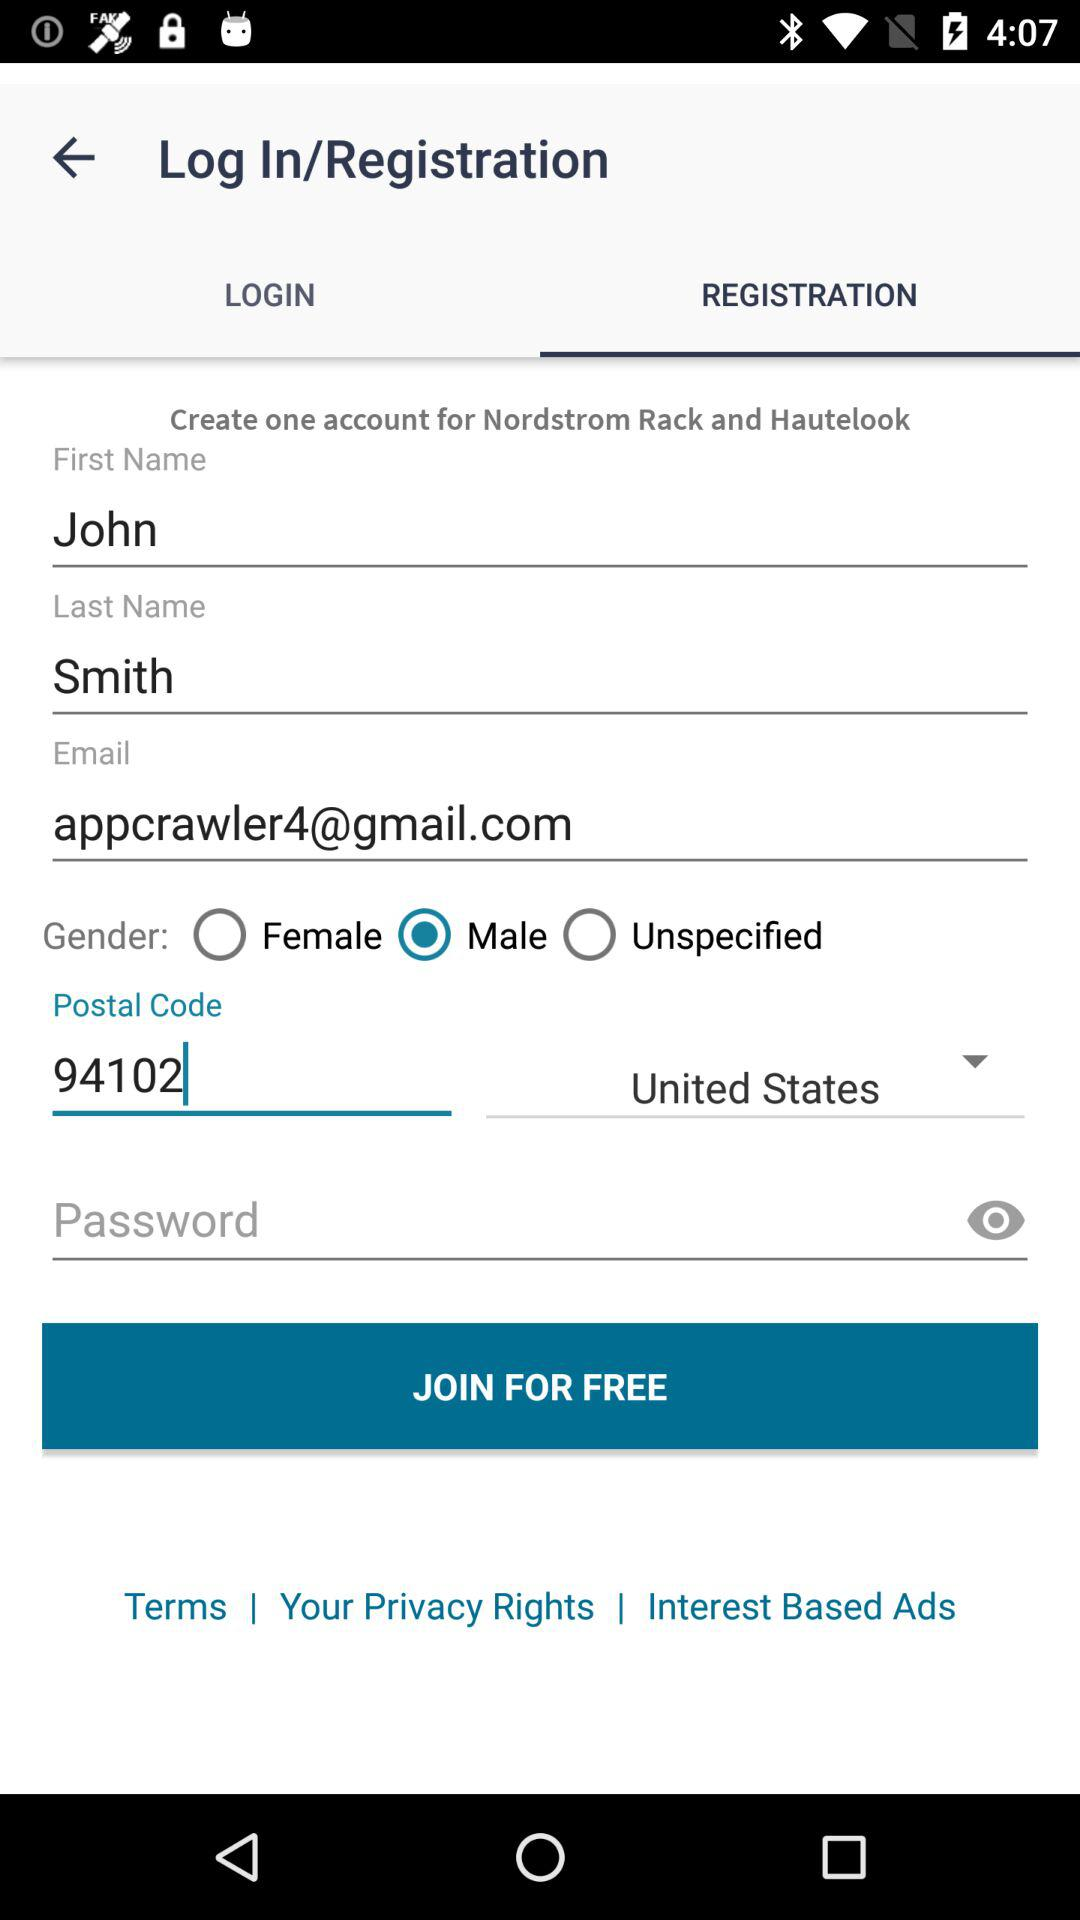What is the first name? The first name is John. 